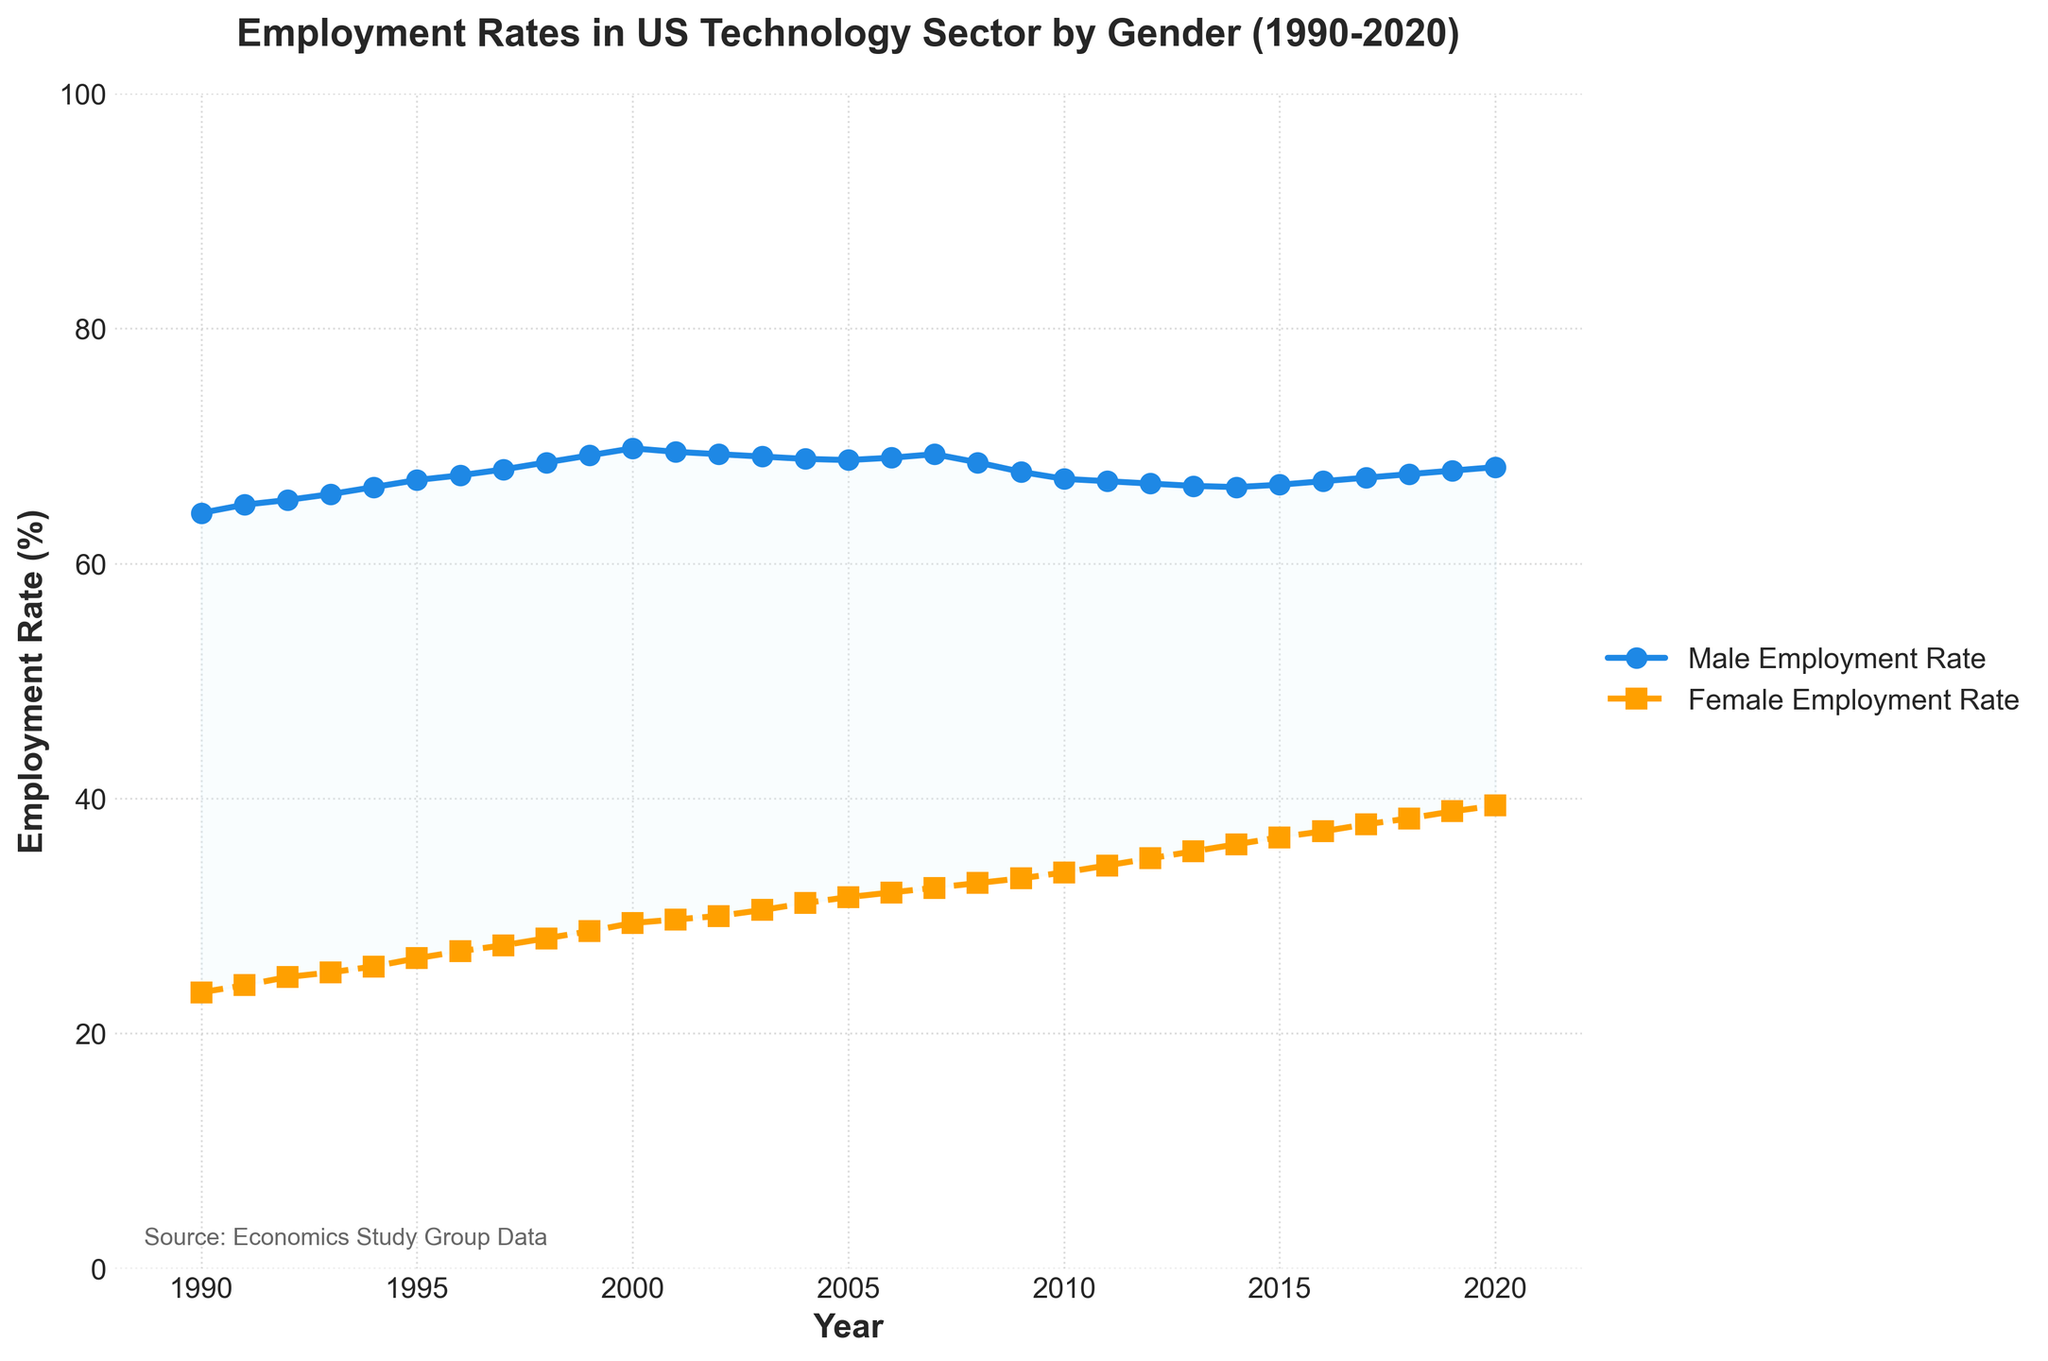What is the title of the plot? The title is located at the top of the figure and provides an overview of the data being represented. It reads: "Employment Rates in US Technology Sector by Gender (1990-2020)".
Answer: Employment Rates in US Technology Sector by Gender (1990-2020) What do the x-axis and y-axis represent in the plot? The x-axis represents the years ranging from 1990 to 2020, and the y-axis represents the employment rates as percentages.
Answer: Years and Employment Rate (%) Which gender had a higher employment rate in the technology sector in 1990? By looking at the beginning data point in 1990, the plot shows that the male employment rate was higher than the female employment rate.
Answer: Male How did the female employment rate change from 1990 to 2020? By observing the figure, the female employment rate steadily increased over the years from 23.5% in 1990 to 39.4% in 2020.
Answer: Increased In which year did female employment rates surpass 30%? Following the female employment rate line, we can see it surpassed 30% in the year 2002.
Answer: 2002 What is the approximate difference in employment rates between males and females in 2020? By referring to the data points for 2020, the male employment rate is approximately 68.2%, and the female employment rate is approximately 39.4%. The difference is calculated as 68.2% - 39.4% = 28.8%.
Answer: 28.8% Did the male employment rate ever decrease over the years captured in the plot? Observing the male employment rate line, we notice decreases intermittently, such as around 2008 and 2009.
Answer: Yes Which gender had a more consistent employment rate trend throughout the years? By analyzing the plot, the male employment rate stayed relatively stable, with minor fluctuations, while the female employment rate showed a more consistent upward trend.
Answer: Female During which period did the female employment rate increase the fastest? The slope of the female employment rate line is steepest between 1995 and 2005, indicating the fastest rate of increase during this period.
Answer: 1995 to 2005 